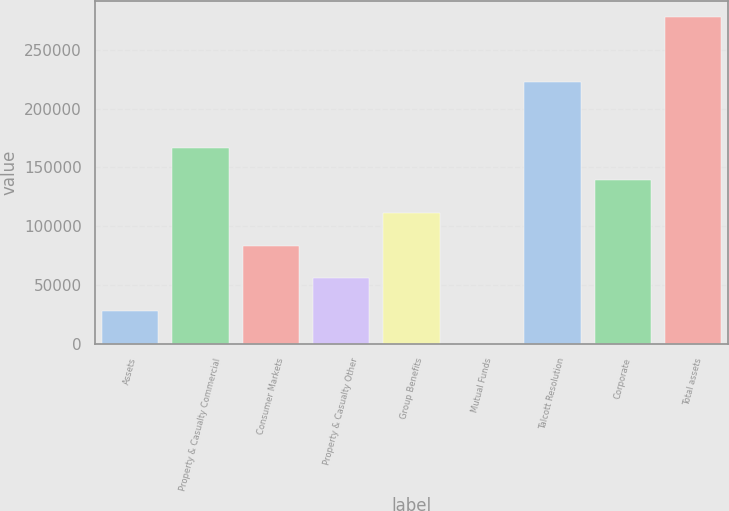Convert chart. <chart><loc_0><loc_0><loc_500><loc_500><bar_chart><fcel>Assets<fcel>Property & Casualty Commercial<fcel>Consumer Markets<fcel>Property & Casualty Other<fcel>Group Benefits<fcel>Mutual Funds<fcel>Talcott Resolution<fcel>Corporate<fcel>Total assets<nl><fcel>28064.7<fcel>166853<fcel>83580.1<fcel>55822.4<fcel>111338<fcel>307<fcel>222269<fcel>139096<fcel>277884<nl></chart> 